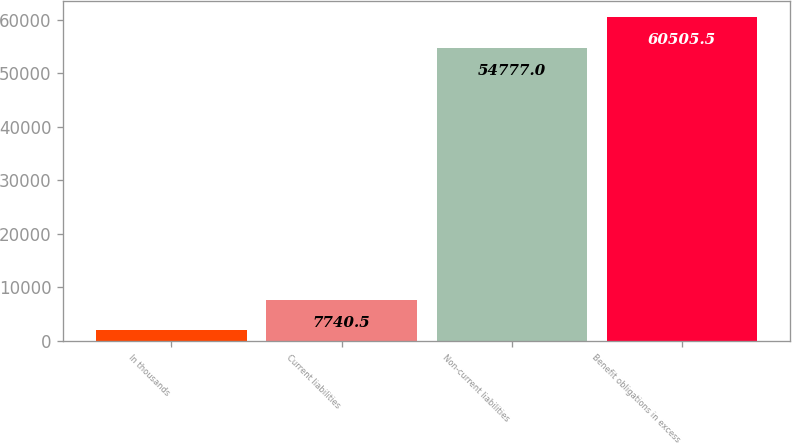Convert chart to OTSL. <chart><loc_0><loc_0><loc_500><loc_500><bar_chart><fcel>In thousands<fcel>Current liabilities<fcel>Non-current liabilities<fcel>Benefit obligations in excess<nl><fcel>2012<fcel>7740.5<fcel>54777<fcel>60505.5<nl></chart> 